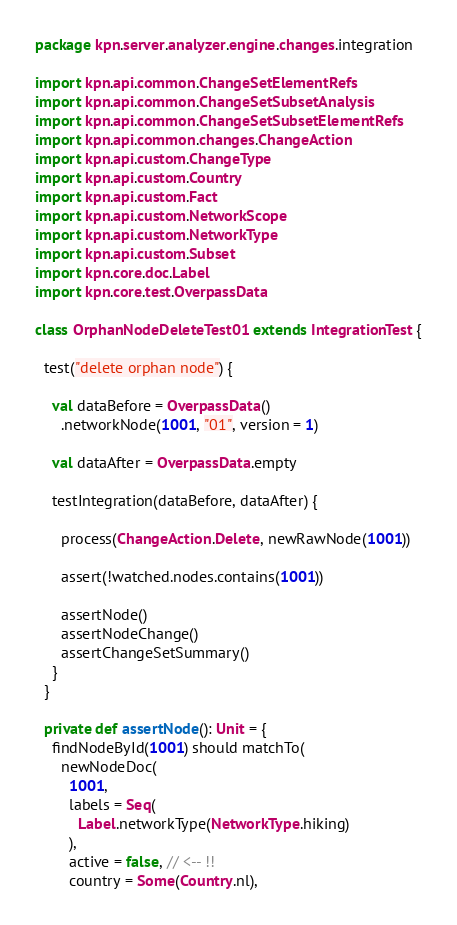Convert code to text. <code><loc_0><loc_0><loc_500><loc_500><_Scala_>package kpn.server.analyzer.engine.changes.integration

import kpn.api.common.ChangeSetElementRefs
import kpn.api.common.ChangeSetSubsetAnalysis
import kpn.api.common.ChangeSetSubsetElementRefs
import kpn.api.common.changes.ChangeAction
import kpn.api.custom.ChangeType
import kpn.api.custom.Country
import kpn.api.custom.Fact
import kpn.api.custom.NetworkScope
import kpn.api.custom.NetworkType
import kpn.api.custom.Subset
import kpn.core.doc.Label
import kpn.core.test.OverpassData

class OrphanNodeDeleteTest01 extends IntegrationTest {

  test("delete orphan node") {

    val dataBefore = OverpassData()
      .networkNode(1001, "01", version = 1)

    val dataAfter = OverpassData.empty

    testIntegration(dataBefore, dataAfter) {

      process(ChangeAction.Delete, newRawNode(1001))

      assert(!watched.nodes.contains(1001))

      assertNode()
      assertNodeChange()
      assertChangeSetSummary()
    }
  }

  private def assertNode(): Unit = {
    findNodeById(1001) should matchTo(
      newNodeDoc(
        1001,
        labels = Seq(
          Label.networkType(NetworkType.hiking)
        ),
        active = false, // <-- !!
        country = Some(Country.nl),</code> 